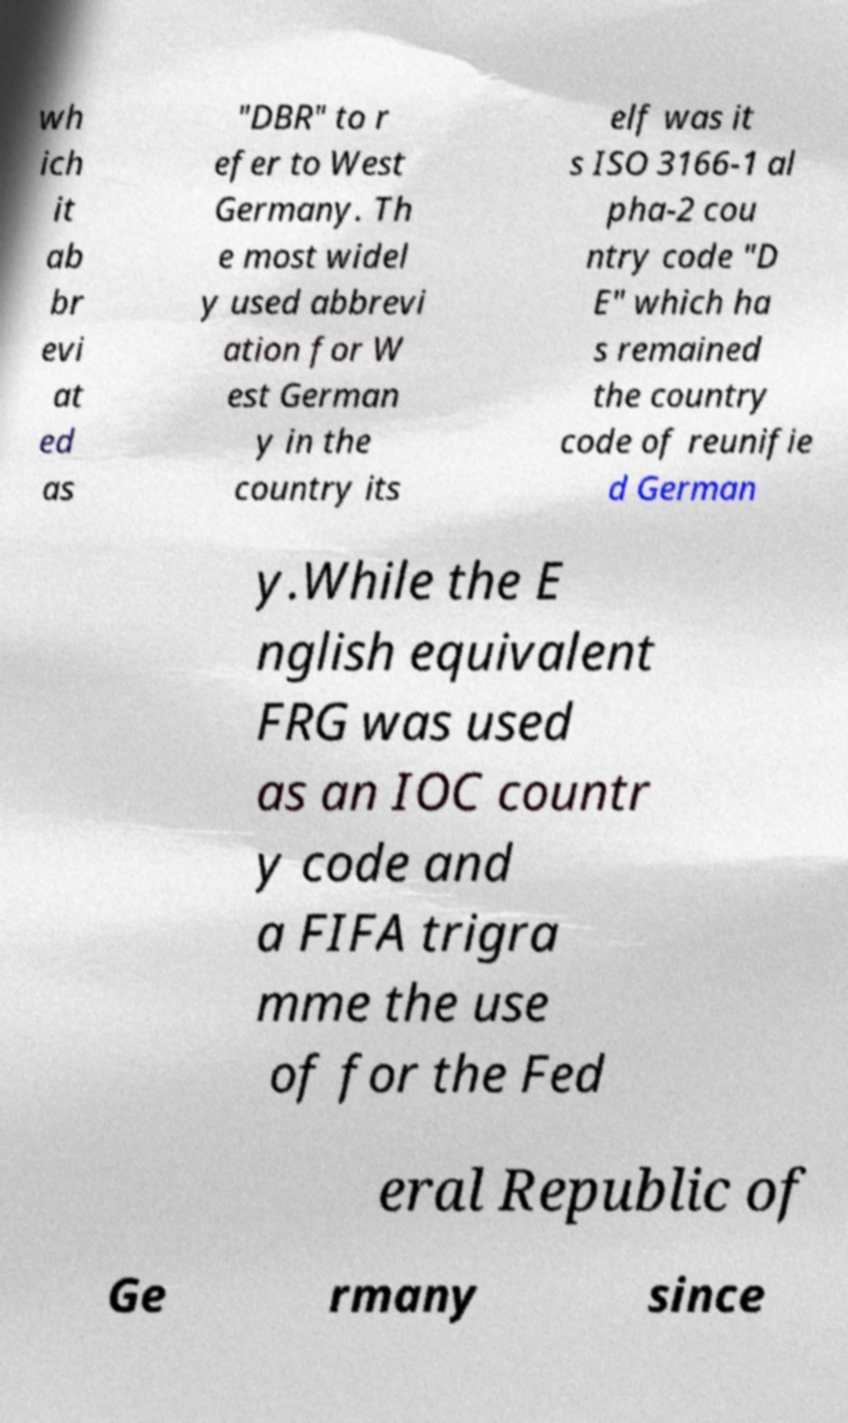I need the written content from this picture converted into text. Can you do that? wh ich it ab br evi at ed as "DBR" to r efer to West Germany. Th e most widel y used abbrevi ation for W est German y in the country its elf was it s ISO 3166-1 al pha-2 cou ntry code "D E" which ha s remained the country code of reunifie d German y.While the E nglish equivalent FRG was used as an IOC countr y code and a FIFA trigra mme the use of for the Fed eral Republic of Ge rmany since 